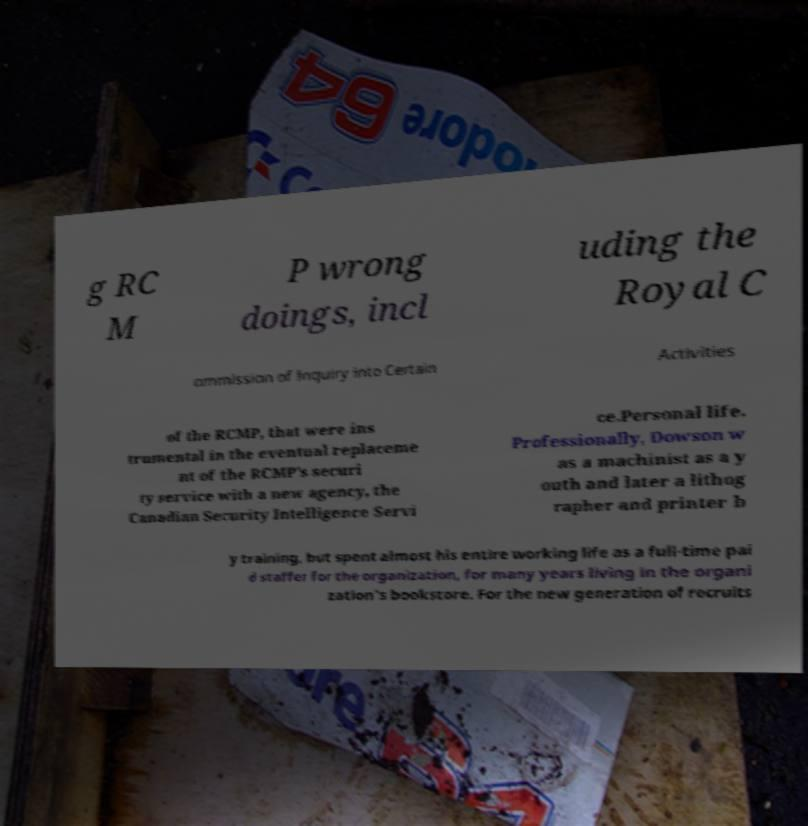Can you read and provide the text displayed in the image?This photo seems to have some interesting text. Can you extract and type it out for me? g RC M P wrong doings, incl uding the Royal C ommission of Inquiry into Certain Activities of the RCMP, that were ins trumental in the eventual replaceme nt of the RCMP's securi ty service with a new agency, the Canadian Security Intelligence Servi ce.Personal life. Professionally, Dowson w as a machinist as a y outh and later a lithog rapher and printer b y training, but spent almost his entire working life as a full-time pai d staffer for the organization, for many years living in the organi zation's bookstore. For the new generation of recruits 